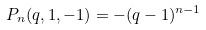<formula> <loc_0><loc_0><loc_500><loc_500>P _ { n } ( q , 1 , - 1 ) = - ( q - 1 ) ^ { n - 1 }</formula> 